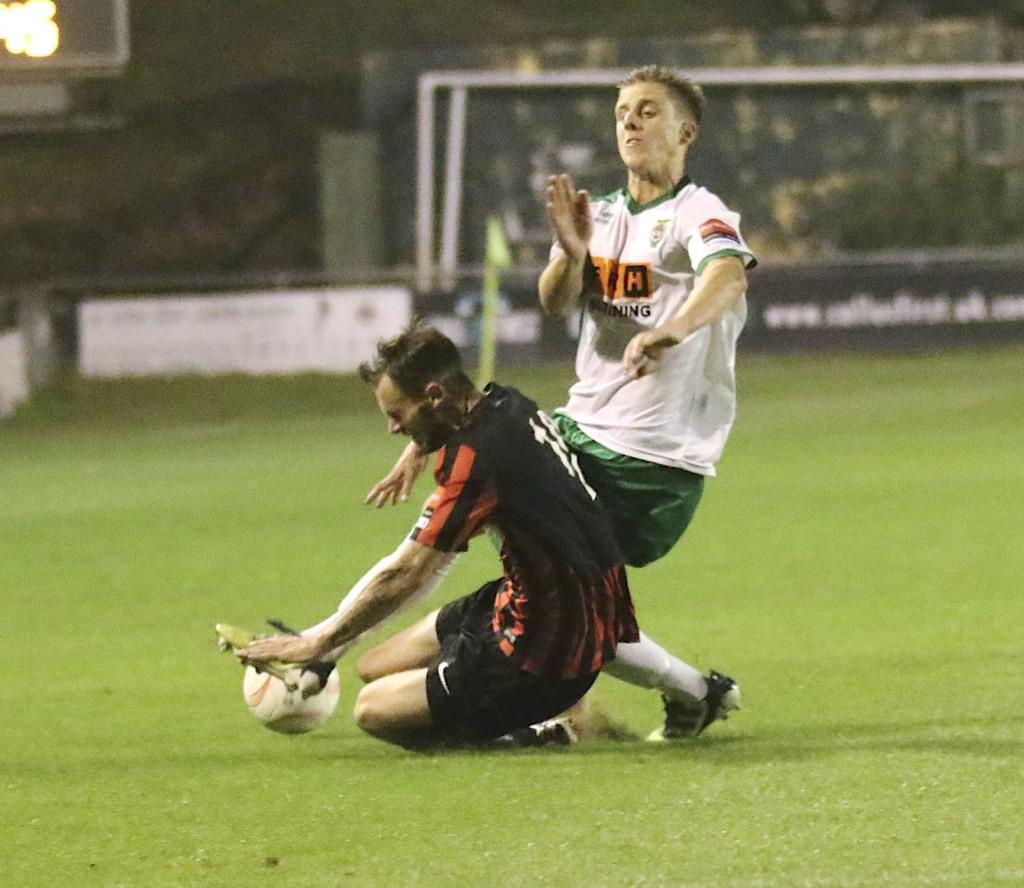Could you give a brief overview of what you see in this image? In this image, we can see green grass on the ground, there are two persons playing a game, we can see a football. 